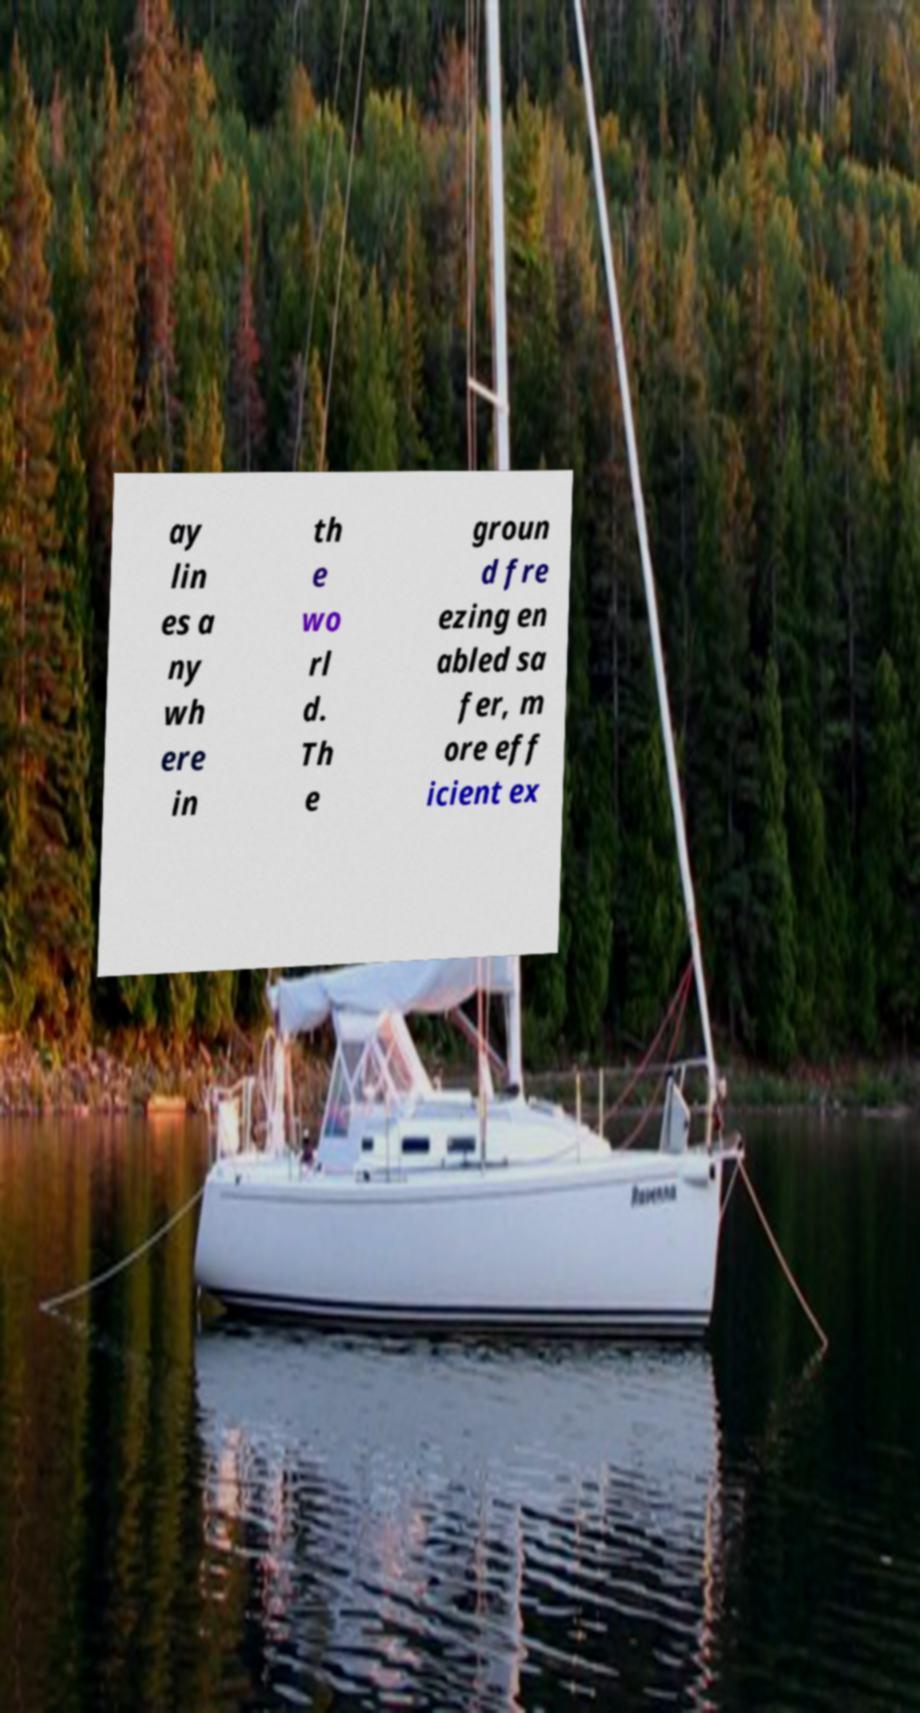Please identify and transcribe the text found in this image. ay lin es a ny wh ere in th e wo rl d. Th e groun d fre ezing en abled sa fer, m ore eff icient ex 